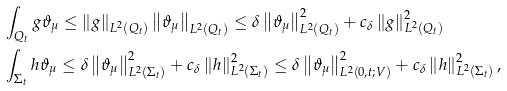Convert formula to latex. <formula><loc_0><loc_0><loc_500><loc_500>& \int _ { Q _ { t } } { g \vartheta _ { \mu } } \leq \left \| g \right \| _ { L ^ { 2 } ( Q _ { t } ) } \left \| \vartheta _ { \mu } \right \| _ { L ^ { 2 } ( Q _ { t } ) } \leq \delta \left \| \vartheta _ { \mu } \right \| ^ { 2 } _ { L ^ { 2 } ( Q _ { t } ) } + c _ { \delta } \left \| g \right \| ^ { 2 } _ { L ^ { 2 } ( Q _ { t } ) } \\ & \int _ { \Sigma _ { t } } { h \vartheta _ { \mu } } \leq \delta \left \| \vartheta _ { \mu } \right \| ^ { 2 } _ { L ^ { 2 } ( \Sigma _ { t } ) } + c _ { \delta } \left \| h \right \| ^ { 2 } _ { L ^ { 2 } ( \Sigma _ { t } ) } \leq \delta \left \| \vartheta _ { \mu } \right \| ^ { 2 } _ { L ^ { 2 } ( 0 , t ; V ) } + c _ { \delta } \left \| h \right \| ^ { 2 } _ { L ^ { 2 } ( \Sigma _ { t } ) } ,</formula> 